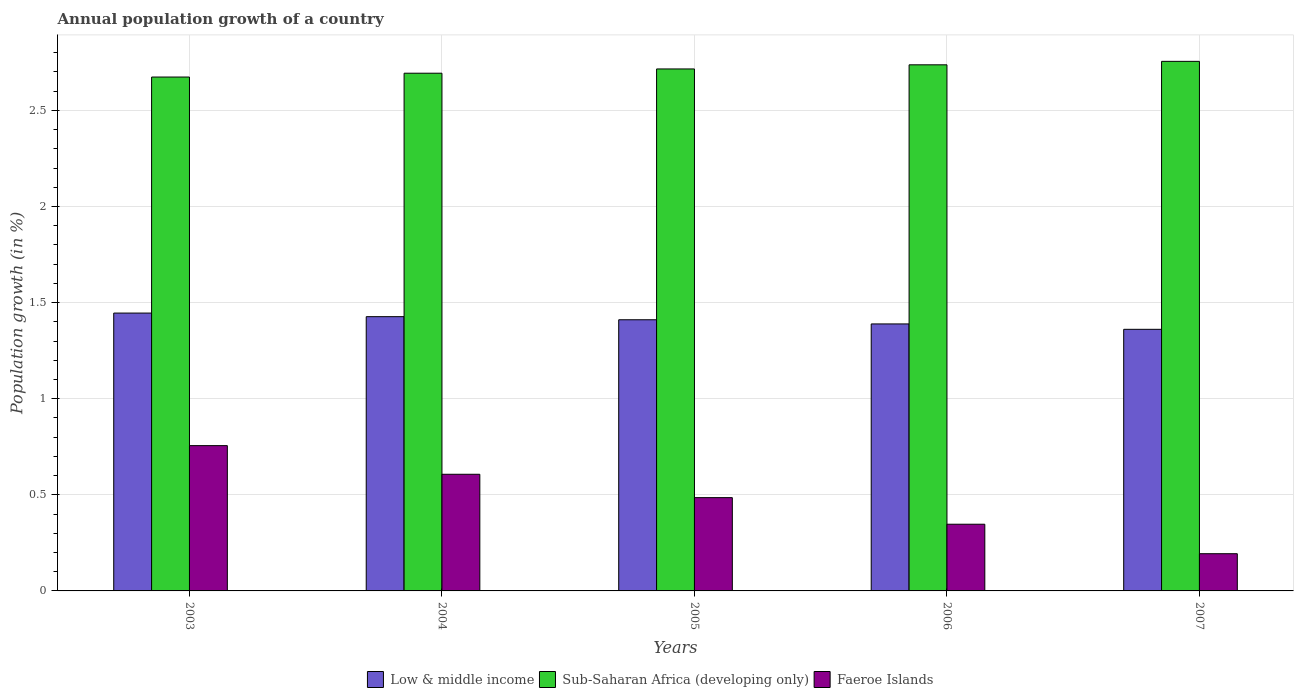How many bars are there on the 5th tick from the right?
Your answer should be compact. 3. What is the label of the 1st group of bars from the left?
Your answer should be very brief. 2003. What is the annual population growth in Low & middle income in 2003?
Give a very brief answer. 1.45. Across all years, what is the maximum annual population growth in Sub-Saharan Africa (developing only)?
Your answer should be very brief. 2.75. Across all years, what is the minimum annual population growth in Sub-Saharan Africa (developing only)?
Ensure brevity in your answer.  2.67. In which year was the annual population growth in Low & middle income maximum?
Make the answer very short. 2003. What is the total annual population growth in Sub-Saharan Africa (developing only) in the graph?
Provide a short and direct response. 13.57. What is the difference between the annual population growth in Faeroe Islands in 2004 and that in 2005?
Give a very brief answer. 0.12. What is the difference between the annual population growth in Faeroe Islands in 2005 and the annual population growth in Low & middle income in 2006?
Your response must be concise. -0.9. What is the average annual population growth in Low & middle income per year?
Your answer should be compact. 1.41. In the year 2007, what is the difference between the annual population growth in Sub-Saharan Africa (developing only) and annual population growth in Low & middle income?
Offer a very short reply. 1.39. What is the ratio of the annual population growth in Faeroe Islands in 2003 to that in 2006?
Your answer should be compact. 2.18. Is the annual population growth in Faeroe Islands in 2004 less than that in 2007?
Give a very brief answer. No. Is the difference between the annual population growth in Sub-Saharan Africa (developing only) in 2004 and 2006 greater than the difference between the annual population growth in Low & middle income in 2004 and 2006?
Provide a succinct answer. No. What is the difference between the highest and the second highest annual population growth in Low & middle income?
Keep it short and to the point. 0.02. What is the difference between the highest and the lowest annual population growth in Sub-Saharan Africa (developing only)?
Ensure brevity in your answer.  0.08. What does the 1st bar from the left in 2003 represents?
Provide a short and direct response. Low & middle income. Are the values on the major ticks of Y-axis written in scientific E-notation?
Your response must be concise. No. Does the graph contain any zero values?
Your answer should be compact. No. Where does the legend appear in the graph?
Your answer should be compact. Bottom center. How are the legend labels stacked?
Offer a very short reply. Horizontal. What is the title of the graph?
Provide a succinct answer. Annual population growth of a country. What is the label or title of the Y-axis?
Make the answer very short. Population growth (in %). What is the Population growth (in %) in Low & middle income in 2003?
Give a very brief answer. 1.45. What is the Population growth (in %) of Sub-Saharan Africa (developing only) in 2003?
Provide a short and direct response. 2.67. What is the Population growth (in %) of Faeroe Islands in 2003?
Provide a short and direct response. 0.76. What is the Population growth (in %) of Low & middle income in 2004?
Make the answer very short. 1.43. What is the Population growth (in %) of Sub-Saharan Africa (developing only) in 2004?
Your answer should be compact. 2.69. What is the Population growth (in %) in Faeroe Islands in 2004?
Your answer should be very brief. 0.61. What is the Population growth (in %) of Low & middle income in 2005?
Your response must be concise. 1.41. What is the Population growth (in %) of Sub-Saharan Africa (developing only) in 2005?
Give a very brief answer. 2.72. What is the Population growth (in %) in Faeroe Islands in 2005?
Offer a terse response. 0.49. What is the Population growth (in %) in Low & middle income in 2006?
Provide a short and direct response. 1.39. What is the Population growth (in %) of Sub-Saharan Africa (developing only) in 2006?
Your answer should be compact. 2.74. What is the Population growth (in %) of Faeroe Islands in 2006?
Your answer should be very brief. 0.35. What is the Population growth (in %) of Low & middle income in 2007?
Make the answer very short. 1.36. What is the Population growth (in %) of Sub-Saharan Africa (developing only) in 2007?
Your answer should be compact. 2.75. What is the Population growth (in %) of Faeroe Islands in 2007?
Ensure brevity in your answer.  0.19. Across all years, what is the maximum Population growth (in %) in Low & middle income?
Give a very brief answer. 1.45. Across all years, what is the maximum Population growth (in %) in Sub-Saharan Africa (developing only)?
Provide a short and direct response. 2.75. Across all years, what is the maximum Population growth (in %) of Faeroe Islands?
Your answer should be very brief. 0.76. Across all years, what is the minimum Population growth (in %) of Low & middle income?
Your response must be concise. 1.36. Across all years, what is the minimum Population growth (in %) in Sub-Saharan Africa (developing only)?
Keep it short and to the point. 2.67. Across all years, what is the minimum Population growth (in %) in Faeroe Islands?
Provide a short and direct response. 0.19. What is the total Population growth (in %) in Low & middle income in the graph?
Ensure brevity in your answer.  7.03. What is the total Population growth (in %) in Sub-Saharan Africa (developing only) in the graph?
Your response must be concise. 13.57. What is the total Population growth (in %) in Faeroe Islands in the graph?
Your answer should be compact. 2.39. What is the difference between the Population growth (in %) in Low & middle income in 2003 and that in 2004?
Keep it short and to the point. 0.02. What is the difference between the Population growth (in %) in Sub-Saharan Africa (developing only) in 2003 and that in 2004?
Your response must be concise. -0.02. What is the difference between the Population growth (in %) of Faeroe Islands in 2003 and that in 2004?
Provide a short and direct response. 0.15. What is the difference between the Population growth (in %) of Low & middle income in 2003 and that in 2005?
Make the answer very short. 0.03. What is the difference between the Population growth (in %) in Sub-Saharan Africa (developing only) in 2003 and that in 2005?
Provide a succinct answer. -0.04. What is the difference between the Population growth (in %) of Faeroe Islands in 2003 and that in 2005?
Keep it short and to the point. 0.27. What is the difference between the Population growth (in %) of Low & middle income in 2003 and that in 2006?
Provide a succinct answer. 0.06. What is the difference between the Population growth (in %) of Sub-Saharan Africa (developing only) in 2003 and that in 2006?
Your answer should be very brief. -0.06. What is the difference between the Population growth (in %) in Faeroe Islands in 2003 and that in 2006?
Your response must be concise. 0.41. What is the difference between the Population growth (in %) in Low & middle income in 2003 and that in 2007?
Offer a very short reply. 0.08. What is the difference between the Population growth (in %) in Sub-Saharan Africa (developing only) in 2003 and that in 2007?
Ensure brevity in your answer.  -0.08. What is the difference between the Population growth (in %) in Faeroe Islands in 2003 and that in 2007?
Your answer should be compact. 0.56. What is the difference between the Population growth (in %) in Low & middle income in 2004 and that in 2005?
Your answer should be very brief. 0.02. What is the difference between the Population growth (in %) in Sub-Saharan Africa (developing only) in 2004 and that in 2005?
Make the answer very short. -0.02. What is the difference between the Population growth (in %) in Faeroe Islands in 2004 and that in 2005?
Make the answer very short. 0.12. What is the difference between the Population growth (in %) in Low & middle income in 2004 and that in 2006?
Make the answer very short. 0.04. What is the difference between the Population growth (in %) of Sub-Saharan Africa (developing only) in 2004 and that in 2006?
Your answer should be compact. -0.04. What is the difference between the Population growth (in %) in Faeroe Islands in 2004 and that in 2006?
Give a very brief answer. 0.26. What is the difference between the Population growth (in %) of Low & middle income in 2004 and that in 2007?
Offer a very short reply. 0.07. What is the difference between the Population growth (in %) of Sub-Saharan Africa (developing only) in 2004 and that in 2007?
Offer a terse response. -0.06. What is the difference between the Population growth (in %) in Faeroe Islands in 2004 and that in 2007?
Offer a terse response. 0.41. What is the difference between the Population growth (in %) in Low & middle income in 2005 and that in 2006?
Provide a succinct answer. 0.02. What is the difference between the Population growth (in %) in Sub-Saharan Africa (developing only) in 2005 and that in 2006?
Provide a short and direct response. -0.02. What is the difference between the Population growth (in %) in Faeroe Islands in 2005 and that in 2006?
Provide a short and direct response. 0.14. What is the difference between the Population growth (in %) of Low & middle income in 2005 and that in 2007?
Keep it short and to the point. 0.05. What is the difference between the Population growth (in %) of Sub-Saharan Africa (developing only) in 2005 and that in 2007?
Provide a short and direct response. -0.04. What is the difference between the Population growth (in %) in Faeroe Islands in 2005 and that in 2007?
Give a very brief answer. 0.29. What is the difference between the Population growth (in %) in Low & middle income in 2006 and that in 2007?
Your answer should be compact. 0.03. What is the difference between the Population growth (in %) in Sub-Saharan Africa (developing only) in 2006 and that in 2007?
Offer a terse response. -0.02. What is the difference between the Population growth (in %) in Faeroe Islands in 2006 and that in 2007?
Make the answer very short. 0.15. What is the difference between the Population growth (in %) of Low & middle income in 2003 and the Population growth (in %) of Sub-Saharan Africa (developing only) in 2004?
Your response must be concise. -1.25. What is the difference between the Population growth (in %) of Low & middle income in 2003 and the Population growth (in %) of Faeroe Islands in 2004?
Give a very brief answer. 0.84. What is the difference between the Population growth (in %) of Sub-Saharan Africa (developing only) in 2003 and the Population growth (in %) of Faeroe Islands in 2004?
Your response must be concise. 2.07. What is the difference between the Population growth (in %) in Low & middle income in 2003 and the Population growth (in %) in Sub-Saharan Africa (developing only) in 2005?
Provide a short and direct response. -1.27. What is the difference between the Population growth (in %) of Low & middle income in 2003 and the Population growth (in %) of Faeroe Islands in 2005?
Offer a very short reply. 0.96. What is the difference between the Population growth (in %) in Sub-Saharan Africa (developing only) in 2003 and the Population growth (in %) in Faeroe Islands in 2005?
Offer a very short reply. 2.19. What is the difference between the Population growth (in %) of Low & middle income in 2003 and the Population growth (in %) of Sub-Saharan Africa (developing only) in 2006?
Keep it short and to the point. -1.29. What is the difference between the Population growth (in %) in Low & middle income in 2003 and the Population growth (in %) in Faeroe Islands in 2006?
Offer a very short reply. 1.1. What is the difference between the Population growth (in %) of Sub-Saharan Africa (developing only) in 2003 and the Population growth (in %) of Faeroe Islands in 2006?
Ensure brevity in your answer.  2.33. What is the difference between the Population growth (in %) of Low & middle income in 2003 and the Population growth (in %) of Sub-Saharan Africa (developing only) in 2007?
Your response must be concise. -1.31. What is the difference between the Population growth (in %) of Low & middle income in 2003 and the Population growth (in %) of Faeroe Islands in 2007?
Make the answer very short. 1.25. What is the difference between the Population growth (in %) of Sub-Saharan Africa (developing only) in 2003 and the Population growth (in %) of Faeroe Islands in 2007?
Your answer should be compact. 2.48. What is the difference between the Population growth (in %) of Low & middle income in 2004 and the Population growth (in %) of Sub-Saharan Africa (developing only) in 2005?
Make the answer very short. -1.29. What is the difference between the Population growth (in %) in Low & middle income in 2004 and the Population growth (in %) in Faeroe Islands in 2005?
Your answer should be very brief. 0.94. What is the difference between the Population growth (in %) in Sub-Saharan Africa (developing only) in 2004 and the Population growth (in %) in Faeroe Islands in 2005?
Provide a short and direct response. 2.21. What is the difference between the Population growth (in %) in Low & middle income in 2004 and the Population growth (in %) in Sub-Saharan Africa (developing only) in 2006?
Give a very brief answer. -1.31. What is the difference between the Population growth (in %) of Low & middle income in 2004 and the Population growth (in %) of Faeroe Islands in 2006?
Your answer should be compact. 1.08. What is the difference between the Population growth (in %) in Sub-Saharan Africa (developing only) in 2004 and the Population growth (in %) in Faeroe Islands in 2006?
Make the answer very short. 2.35. What is the difference between the Population growth (in %) of Low & middle income in 2004 and the Population growth (in %) of Sub-Saharan Africa (developing only) in 2007?
Provide a succinct answer. -1.33. What is the difference between the Population growth (in %) of Low & middle income in 2004 and the Population growth (in %) of Faeroe Islands in 2007?
Your response must be concise. 1.23. What is the difference between the Population growth (in %) in Sub-Saharan Africa (developing only) in 2004 and the Population growth (in %) in Faeroe Islands in 2007?
Ensure brevity in your answer.  2.5. What is the difference between the Population growth (in %) in Low & middle income in 2005 and the Population growth (in %) in Sub-Saharan Africa (developing only) in 2006?
Provide a succinct answer. -1.33. What is the difference between the Population growth (in %) in Low & middle income in 2005 and the Population growth (in %) in Faeroe Islands in 2006?
Your response must be concise. 1.06. What is the difference between the Population growth (in %) in Sub-Saharan Africa (developing only) in 2005 and the Population growth (in %) in Faeroe Islands in 2006?
Your response must be concise. 2.37. What is the difference between the Population growth (in %) of Low & middle income in 2005 and the Population growth (in %) of Sub-Saharan Africa (developing only) in 2007?
Give a very brief answer. -1.34. What is the difference between the Population growth (in %) of Low & middle income in 2005 and the Population growth (in %) of Faeroe Islands in 2007?
Make the answer very short. 1.22. What is the difference between the Population growth (in %) of Sub-Saharan Africa (developing only) in 2005 and the Population growth (in %) of Faeroe Islands in 2007?
Provide a succinct answer. 2.52. What is the difference between the Population growth (in %) of Low & middle income in 2006 and the Population growth (in %) of Sub-Saharan Africa (developing only) in 2007?
Ensure brevity in your answer.  -1.37. What is the difference between the Population growth (in %) of Low & middle income in 2006 and the Population growth (in %) of Faeroe Islands in 2007?
Your answer should be very brief. 1.2. What is the difference between the Population growth (in %) in Sub-Saharan Africa (developing only) in 2006 and the Population growth (in %) in Faeroe Islands in 2007?
Offer a very short reply. 2.54. What is the average Population growth (in %) of Low & middle income per year?
Offer a very short reply. 1.41. What is the average Population growth (in %) in Sub-Saharan Africa (developing only) per year?
Provide a succinct answer. 2.71. What is the average Population growth (in %) of Faeroe Islands per year?
Offer a very short reply. 0.48. In the year 2003, what is the difference between the Population growth (in %) in Low & middle income and Population growth (in %) in Sub-Saharan Africa (developing only)?
Offer a terse response. -1.23. In the year 2003, what is the difference between the Population growth (in %) in Low & middle income and Population growth (in %) in Faeroe Islands?
Your answer should be very brief. 0.69. In the year 2003, what is the difference between the Population growth (in %) of Sub-Saharan Africa (developing only) and Population growth (in %) of Faeroe Islands?
Your answer should be compact. 1.92. In the year 2004, what is the difference between the Population growth (in %) in Low & middle income and Population growth (in %) in Sub-Saharan Africa (developing only)?
Provide a short and direct response. -1.27. In the year 2004, what is the difference between the Population growth (in %) in Low & middle income and Population growth (in %) in Faeroe Islands?
Your answer should be compact. 0.82. In the year 2004, what is the difference between the Population growth (in %) in Sub-Saharan Africa (developing only) and Population growth (in %) in Faeroe Islands?
Your answer should be very brief. 2.09. In the year 2005, what is the difference between the Population growth (in %) of Low & middle income and Population growth (in %) of Sub-Saharan Africa (developing only)?
Offer a terse response. -1.3. In the year 2005, what is the difference between the Population growth (in %) of Low & middle income and Population growth (in %) of Faeroe Islands?
Provide a short and direct response. 0.93. In the year 2005, what is the difference between the Population growth (in %) of Sub-Saharan Africa (developing only) and Population growth (in %) of Faeroe Islands?
Provide a short and direct response. 2.23. In the year 2006, what is the difference between the Population growth (in %) of Low & middle income and Population growth (in %) of Sub-Saharan Africa (developing only)?
Provide a succinct answer. -1.35. In the year 2006, what is the difference between the Population growth (in %) in Low & middle income and Population growth (in %) in Faeroe Islands?
Make the answer very short. 1.04. In the year 2006, what is the difference between the Population growth (in %) of Sub-Saharan Africa (developing only) and Population growth (in %) of Faeroe Islands?
Your answer should be compact. 2.39. In the year 2007, what is the difference between the Population growth (in %) in Low & middle income and Population growth (in %) in Sub-Saharan Africa (developing only)?
Offer a very short reply. -1.39. In the year 2007, what is the difference between the Population growth (in %) in Low & middle income and Population growth (in %) in Faeroe Islands?
Offer a very short reply. 1.17. In the year 2007, what is the difference between the Population growth (in %) of Sub-Saharan Africa (developing only) and Population growth (in %) of Faeroe Islands?
Keep it short and to the point. 2.56. What is the ratio of the Population growth (in %) of Low & middle income in 2003 to that in 2004?
Your response must be concise. 1.01. What is the ratio of the Population growth (in %) of Faeroe Islands in 2003 to that in 2004?
Provide a short and direct response. 1.25. What is the ratio of the Population growth (in %) of Low & middle income in 2003 to that in 2005?
Give a very brief answer. 1.02. What is the ratio of the Population growth (in %) of Sub-Saharan Africa (developing only) in 2003 to that in 2005?
Ensure brevity in your answer.  0.98. What is the ratio of the Population growth (in %) of Faeroe Islands in 2003 to that in 2005?
Your answer should be very brief. 1.56. What is the ratio of the Population growth (in %) of Low & middle income in 2003 to that in 2006?
Your answer should be compact. 1.04. What is the ratio of the Population growth (in %) of Sub-Saharan Africa (developing only) in 2003 to that in 2006?
Give a very brief answer. 0.98. What is the ratio of the Population growth (in %) in Faeroe Islands in 2003 to that in 2006?
Offer a very short reply. 2.18. What is the ratio of the Population growth (in %) in Low & middle income in 2003 to that in 2007?
Offer a very short reply. 1.06. What is the ratio of the Population growth (in %) of Sub-Saharan Africa (developing only) in 2003 to that in 2007?
Offer a very short reply. 0.97. What is the ratio of the Population growth (in %) of Faeroe Islands in 2003 to that in 2007?
Ensure brevity in your answer.  3.9. What is the ratio of the Population growth (in %) of Low & middle income in 2004 to that in 2005?
Your answer should be very brief. 1.01. What is the ratio of the Population growth (in %) in Faeroe Islands in 2004 to that in 2005?
Your answer should be very brief. 1.25. What is the ratio of the Population growth (in %) of Low & middle income in 2004 to that in 2006?
Make the answer very short. 1.03. What is the ratio of the Population growth (in %) in Sub-Saharan Africa (developing only) in 2004 to that in 2006?
Provide a short and direct response. 0.98. What is the ratio of the Population growth (in %) in Faeroe Islands in 2004 to that in 2006?
Make the answer very short. 1.75. What is the ratio of the Population growth (in %) in Low & middle income in 2004 to that in 2007?
Keep it short and to the point. 1.05. What is the ratio of the Population growth (in %) in Sub-Saharan Africa (developing only) in 2004 to that in 2007?
Keep it short and to the point. 0.98. What is the ratio of the Population growth (in %) in Faeroe Islands in 2004 to that in 2007?
Offer a terse response. 3.13. What is the ratio of the Population growth (in %) in Low & middle income in 2005 to that in 2006?
Make the answer very short. 1.02. What is the ratio of the Population growth (in %) of Sub-Saharan Africa (developing only) in 2005 to that in 2006?
Give a very brief answer. 0.99. What is the ratio of the Population growth (in %) in Faeroe Islands in 2005 to that in 2006?
Provide a short and direct response. 1.4. What is the ratio of the Population growth (in %) of Low & middle income in 2005 to that in 2007?
Give a very brief answer. 1.04. What is the ratio of the Population growth (in %) in Sub-Saharan Africa (developing only) in 2005 to that in 2007?
Give a very brief answer. 0.99. What is the ratio of the Population growth (in %) of Faeroe Islands in 2005 to that in 2007?
Your answer should be compact. 2.51. What is the ratio of the Population growth (in %) in Low & middle income in 2006 to that in 2007?
Provide a short and direct response. 1.02. What is the ratio of the Population growth (in %) in Sub-Saharan Africa (developing only) in 2006 to that in 2007?
Ensure brevity in your answer.  0.99. What is the ratio of the Population growth (in %) in Faeroe Islands in 2006 to that in 2007?
Offer a terse response. 1.79. What is the difference between the highest and the second highest Population growth (in %) in Low & middle income?
Offer a terse response. 0.02. What is the difference between the highest and the second highest Population growth (in %) of Sub-Saharan Africa (developing only)?
Provide a short and direct response. 0.02. What is the difference between the highest and the second highest Population growth (in %) of Faeroe Islands?
Offer a terse response. 0.15. What is the difference between the highest and the lowest Population growth (in %) in Low & middle income?
Ensure brevity in your answer.  0.08. What is the difference between the highest and the lowest Population growth (in %) in Sub-Saharan Africa (developing only)?
Make the answer very short. 0.08. What is the difference between the highest and the lowest Population growth (in %) in Faeroe Islands?
Ensure brevity in your answer.  0.56. 